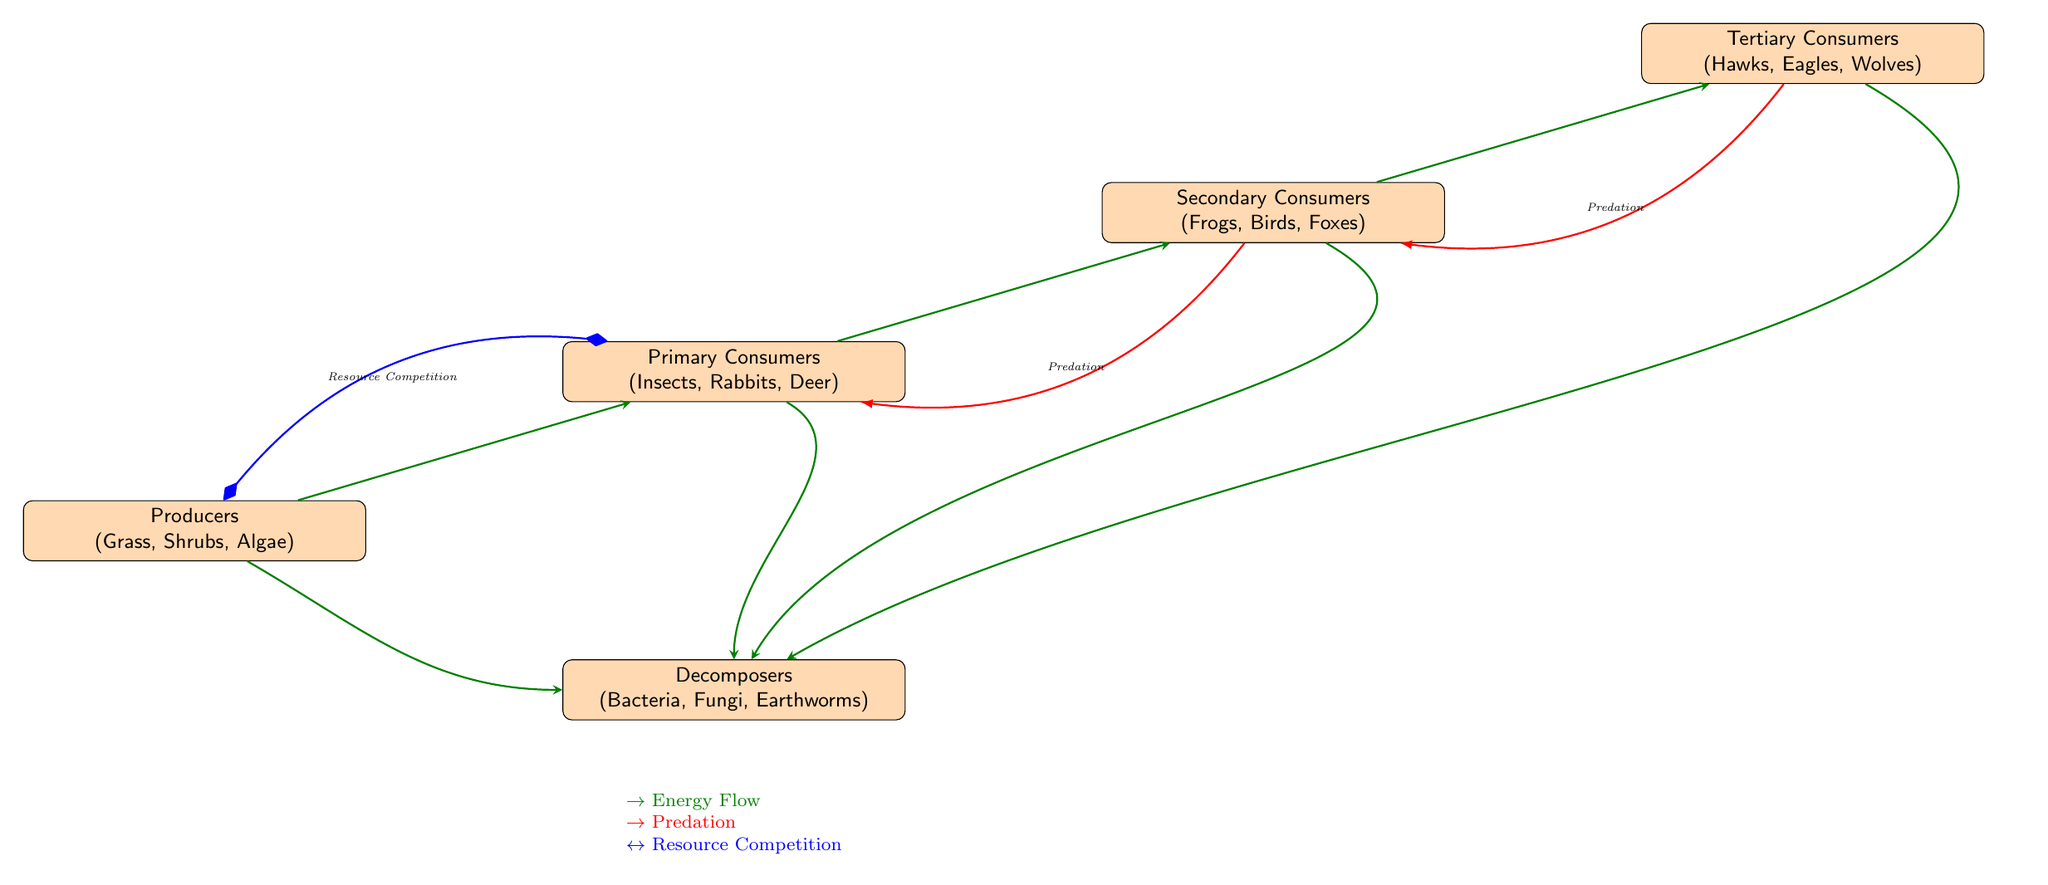What are the primary consumers in this ecosystem? The primary consumers are listed directly in the diagram under the "Primary Consumers" node. They include insects, rabbits, and deer.
Answer: Insects, Rabbits, Deer Which trophic level has the decomposers? The decomposers are shown in a separate node labeled "Decomposers" which is below the producers. This indicates their position in the ecosystem.
Answer: Decomposers How many trophic levels are represented in the diagram? The diagram outlines four distinct trophic levels: producers, primary consumers, secondary consumers, and tertiary consumers.
Answer: Four What interaction occurs between secondary and primary consumers? The diagram indicates a predation interaction connecting the secondary consumers to the primary consumers, which is labeled with an arrow and the term "Predation."
Answer: Predation Which competition is shown between primary consumers and producers? The diagram illustrates resource competition with a two-way arrow labeled "Resource Competition" between the primary consumers and the producers, indicating competition for resources.
Answer: Resource Competition Identify the direction of energy flow from producers to tertiary consumers. The energy flow is represented with arrows directed upward from producers to primary, then secondary, and finally to tertiary consumers, showing a clear path of energy transfer.
Answer: Upward What type of relationship is indicated by the arrows between decomposers and all trophic levels? The arrows from all trophic levels to the decomposers with "Energy Flow" indicate a relationship showing that energy and organic matter from consumers and producers are returned to the decomposers.
Answer: Energy Flow Who are the tertiary consumers in this ecosystem? The tertiary consumers are specified in the diagram under the "Tertiary Consumers" label, including hawks, eagles, and wolves.
Answer: Hawks, Eagles, Wolves What is the interaction type from tertiary consumers back to secondary consumers? The diagram displays a predation interaction from tertiary to secondary consumers, indicated with an arrow labeled "Predation" which signifies that tertiary consumers prey on secondary consumers.
Answer: Predation Explain the relationship between primary consumers and producers shown in the diagram. The diagram shows a resource competition using a bidirectional arrow between primary consumers and producers, suggesting this audience competes for the same resources found in the ecosystem.
Answer: Resource Competition 